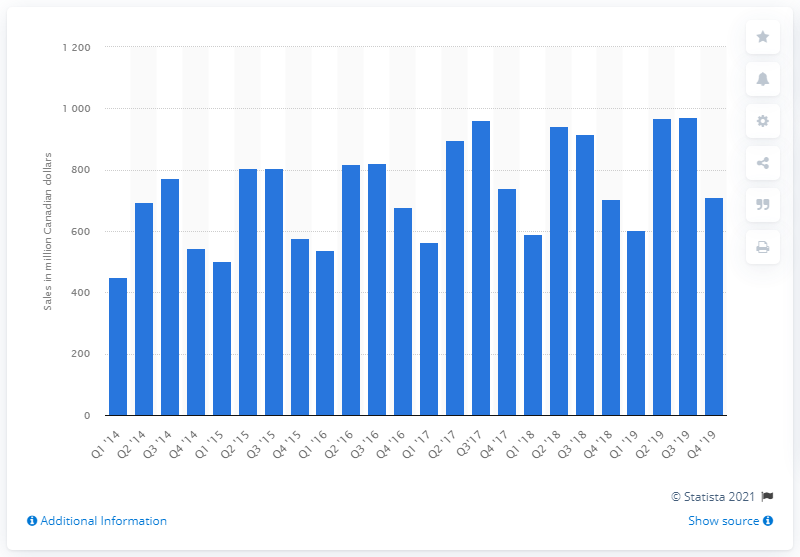Outline some significant characteristics in this image. In the fourth quarter of 2019, a total of 710.44 units of paint, wallpaper, and related supplies were sold in Canada. 